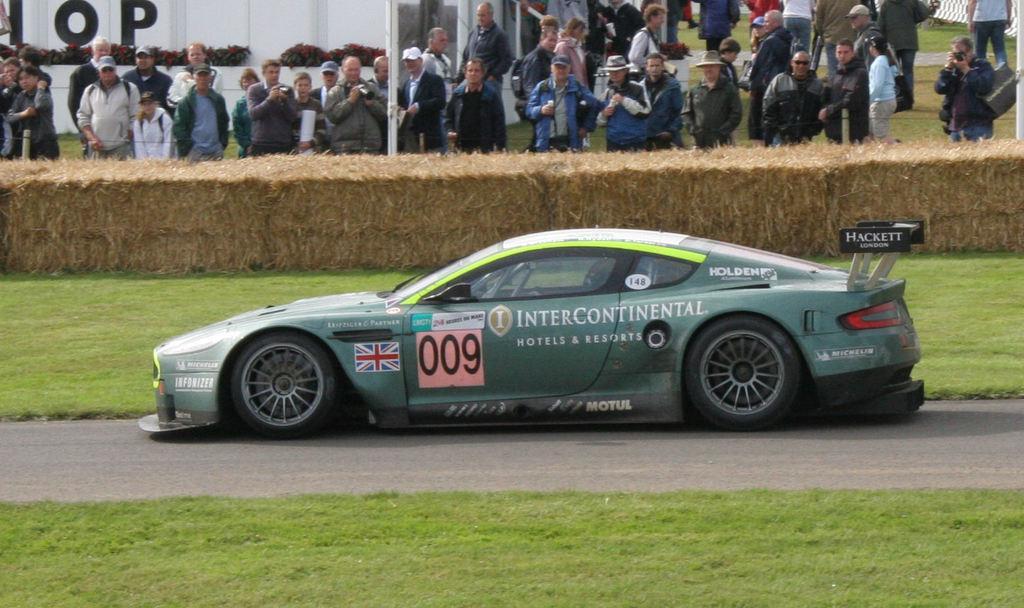In one or two sentences, can you explain what this image depicts? There is a sports car in the center of the image and there is grassland at the bottom side. There are people, plants, and a pole at the top side in front of bales. 